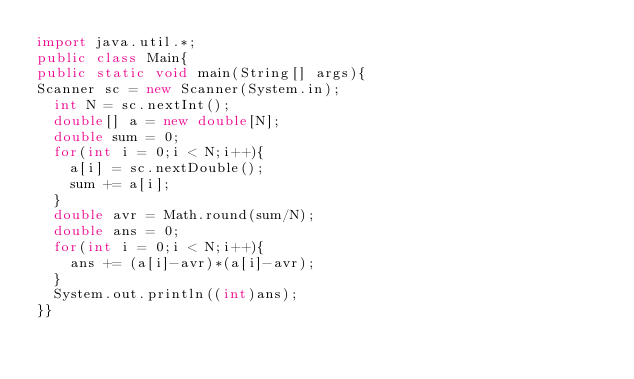Convert code to text. <code><loc_0><loc_0><loc_500><loc_500><_Java_>import java.util.*;
public class Main{
public static void main(String[] args){
Scanner sc = new Scanner(System.in);
  int N = sc.nextInt();
  double[] a = new double[N];
  double sum = 0;
  for(int i = 0;i < N;i++){
    a[i] = sc.nextDouble();
    sum += a[i];
  }
  double avr = Math.round(sum/N);
  double ans = 0;
  for(int i = 0;i < N;i++){
    ans += (a[i]-avr)*(a[i]-avr);
  }
  System.out.println((int)ans);
}}</code> 